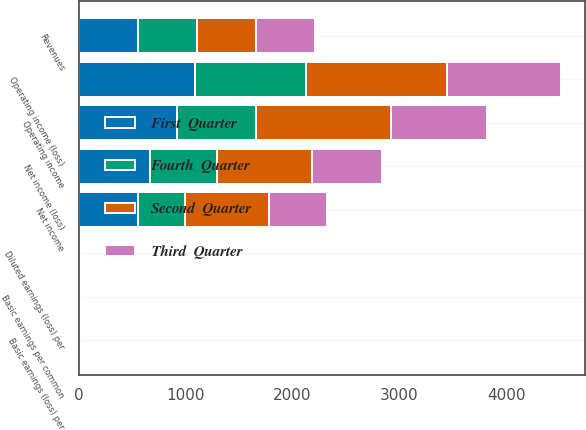Convert chart to OTSL. <chart><loc_0><loc_0><loc_500><loc_500><stacked_bar_chart><ecel><fcel>Revenues<fcel>Operating income (loss)<fcel>Net income (loss)<fcel>Basic earnings (loss) per<fcel>Diluted earnings (loss) per<fcel>Operating income<fcel>Net income<fcel>Basic earnings per common<nl><fcel>Third  Quarter<fcel>553.5<fcel>1062<fcel>653<fcel>2.29<fcel>2.26<fcel>891<fcel>548<fcel>1.73<nl><fcel>First  Quarter<fcel>553.5<fcel>1088<fcel>663<fcel>2.34<fcel>2.31<fcel>923<fcel>559<fcel>1.77<nl><fcel>Fourth  Quarter<fcel>553.5<fcel>1038<fcel>628<fcel>2.21<fcel>2.18<fcel>737<fcel>437<fcel>1.44<nl><fcel>Second  Quarter<fcel>553.5<fcel>1321<fcel>895<fcel>3.16<fcel>3.16<fcel>1264<fcel>780<fcel>2.66<nl></chart> 